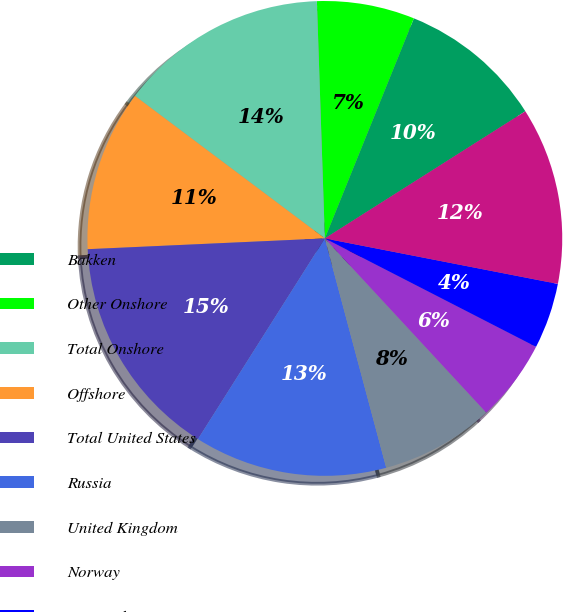<chart> <loc_0><loc_0><loc_500><loc_500><pie_chart><fcel>Bakken<fcel>Other Onshore<fcel>Total Onshore<fcel>Offshore<fcel>Total United States<fcel>Russia<fcel>United Kingdom<fcel>Norway<fcel>Denmark<fcel>Equatorial Guinea<nl><fcel>9.89%<fcel>6.65%<fcel>14.22%<fcel>10.97%<fcel>15.3%<fcel>13.14%<fcel>7.73%<fcel>5.56%<fcel>4.48%<fcel>12.06%<nl></chart> 